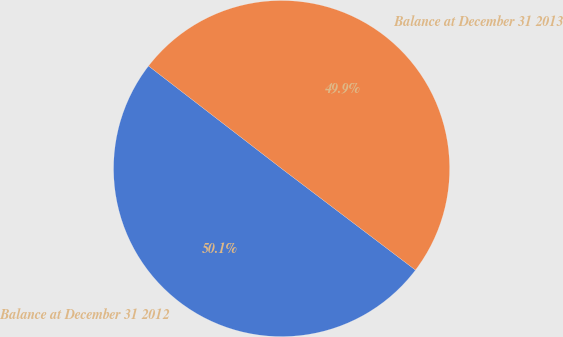Convert chart. <chart><loc_0><loc_0><loc_500><loc_500><pie_chart><fcel>Balance at December 31 2012<fcel>Balance at December 31 2013<nl><fcel>50.13%<fcel>49.87%<nl></chart> 